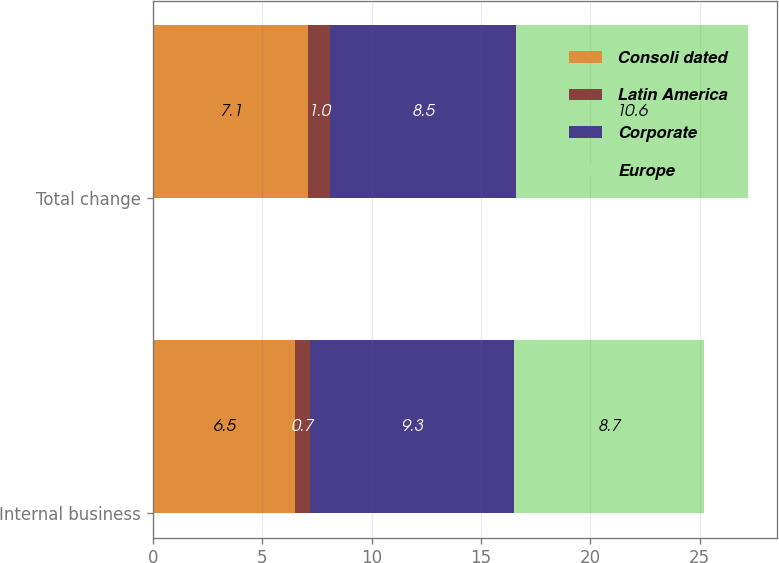Convert chart to OTSL. <chart><loc_0><loc_0><loc_500><loc_500><stacked_bar_chart><ecel><fcel>Internal business<fcel>Total change<nl><fcel>Consoli dated<fcel>6.5<fcel>7.1<nl><fcel>Latin America<fcel>0.7<fcel>1<nl><fcel>Corporate<fcel>9.3<fcel>8.5<nl><fcel>Europe<fcel>8.7<fcel>10.6<nl></chart> 